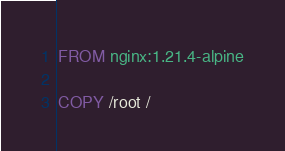<code> <loc_0><loc_0><loc_500><loc_500><_Dockerfile_>FROM nginx:1.21.4-alpine

COPY /root /
</code> 